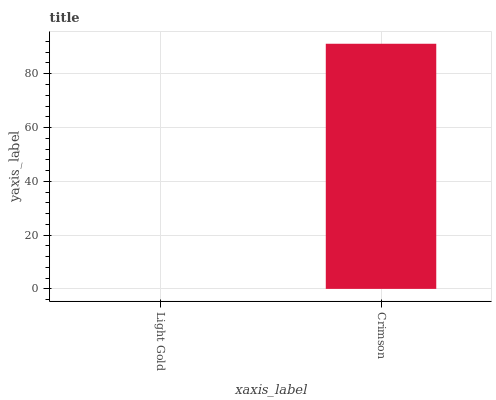Is Light Gold the minimum?
Answer yes or no. Yes. Is Crimson the maximum?
Answer yes or no. Yes. Is Crimson the minimum?
Answer yes or no. No. Is Crimson greater than Light Gold?
Answer yes or no. Yes. Is Light Gold less than Crimson?
Answer yes or no. Yes. Is Light Gold greater than Crimson?
Answer yes or no. No. Is Crimson less than Light Gold?
Answer yes or no. No. Is Crimson the high median?
Answer yes or no. Yes. Is Light Gold the low median?
Answer yes or no. Yes. Is Light Gold the high median?
Answer yes or no. No. Is Crimson the low median?
Answer yes or no. No. 